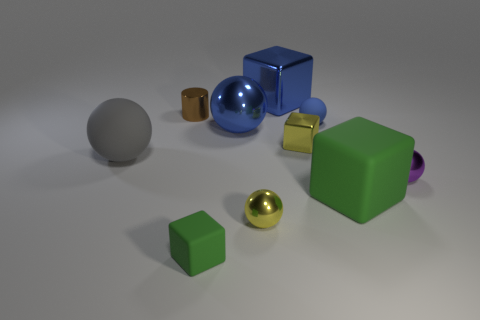Subtract all yellow balls. How many balls are left? 4 Subtract all small purple metallic balls. How many balls are left? 4 Subtract all green balls. Subtract all purple blocks. How many balls are left? 5 Subtract all blocks. How many objects are left? 6 Add 4 blue metal cubes. How many blue metal cubes are left? 5 Add 5 blue matte spheres. How many blue matte spheres exist? 6 Subtract 1 green blocks. How many objects are left? 9 Subtract all small blue rubber balls. Subtract all small cylinders. How many objects are left? 8 